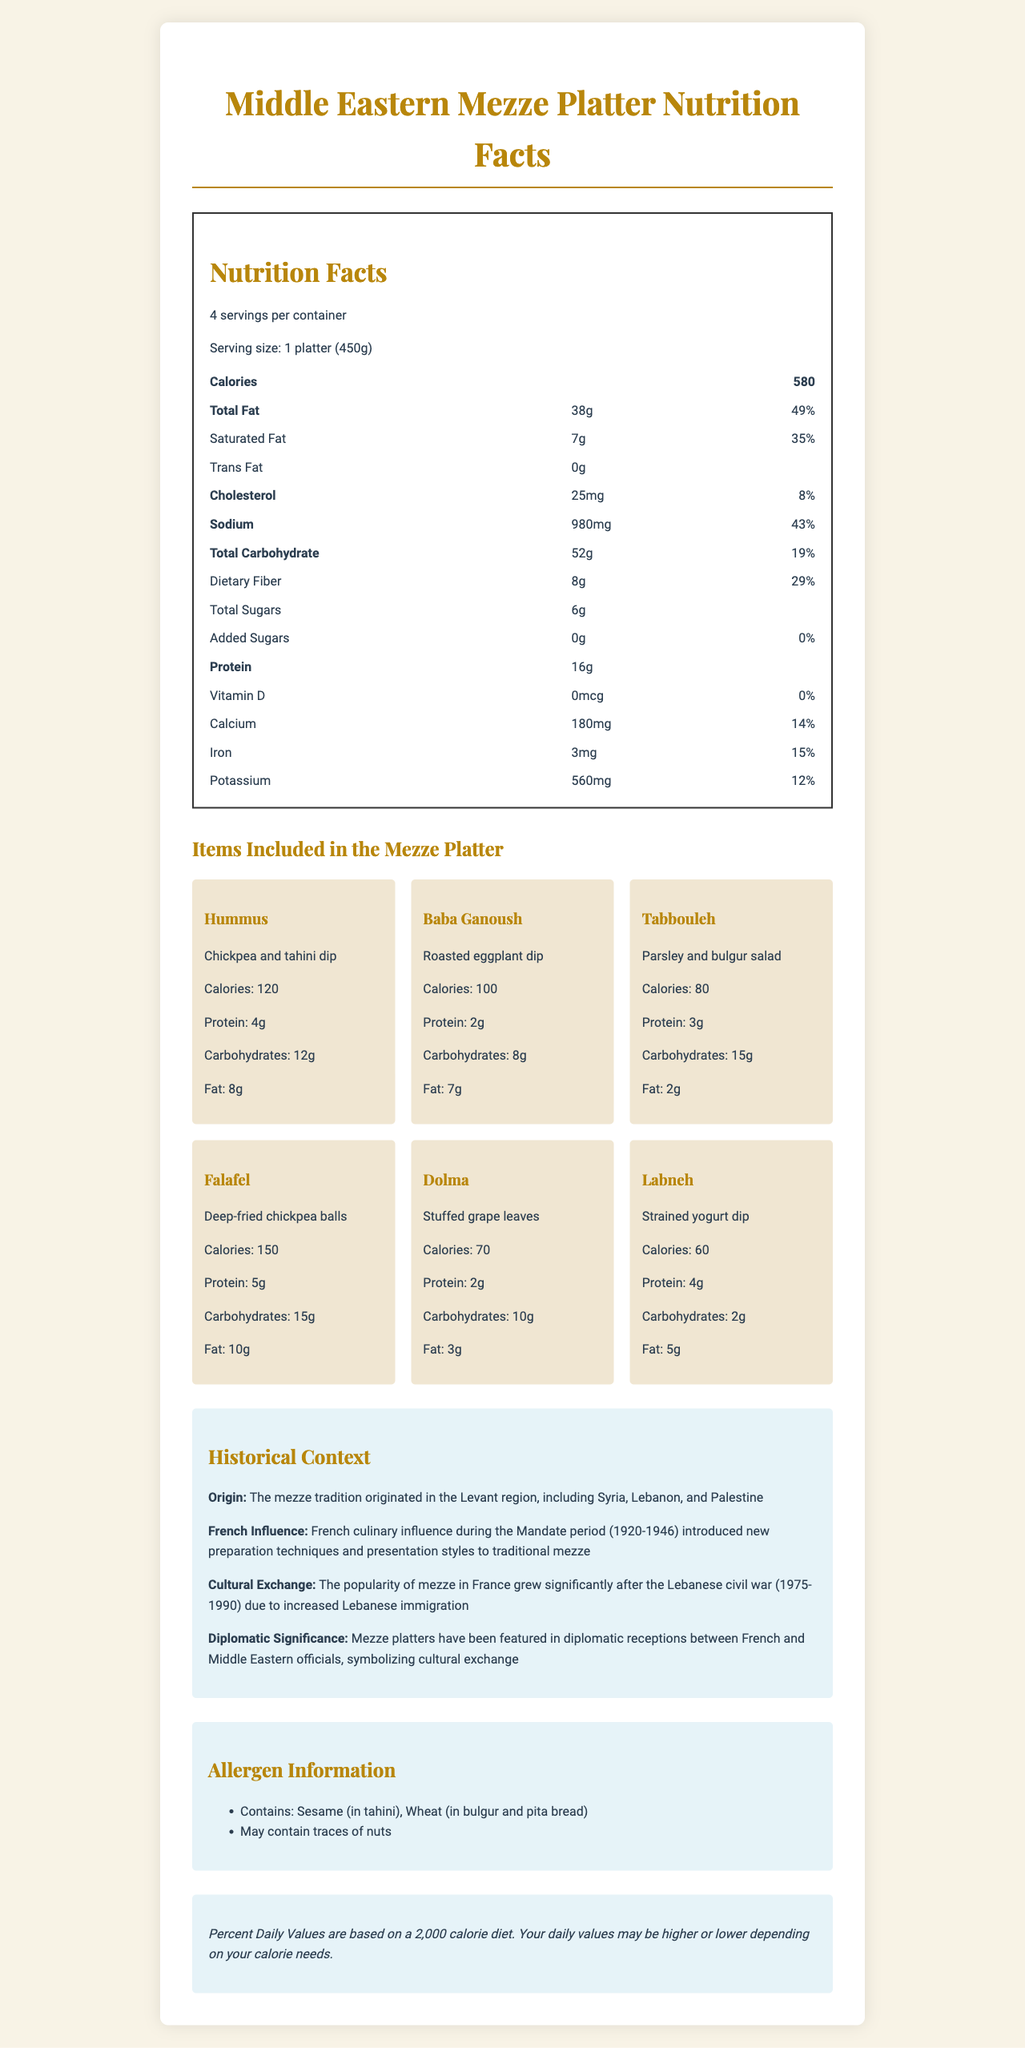what is the serving size for the mezze platter? The document specifies that the serving size is "1 platter (450g)".
Answer: 1 platter (450g) how many grams of total fat are in a serving of the mezze platter? According to the nutritional facts, the total fat per serving is listed as 38g.
Answer: 38g how many grams of dietary fiber does the mezze platter contain per serving? The nutrition label indicates that each serving contains 8g of dietary fiber.
Answer: 8g what is the daily value percentage for sodium in a serving of the mezze platter? The document states that the daily value percentage for sodium is 43%.
Answer: 43% how much protein is found in the Labneh dip included in the mezze platter? The details for Labneh indicate that it contains 4g of protein per serving.
Answer: 4g which item has the highest number of calories in the mezze platter? A. Hummus B. Falafel C. Tabbouleh D. Dolma The calorie content for each item is listed, with Falafel having the highest at 150 calories.
Answer: B how many grams of carbohydrates are in a serving of Falafel? A. 10g B. 15g C. 20g D. 25g The nutrition facts for Falafel state it contains 15g of carbohydrates.
Answer: B does the mezze platter contain any added sugars? The document shows 0g of added sugars, indicating there are no added sugars.
Answer: No is there any Vitamin D in the mezze platter? The Vitamin D content is listed as 0mcg with a 0% daily value, indicating there is no Vitamin D.
Answer: No summarize the historical context of the mezze platter. The historical context section covers the origin of the mezze tradition in the Levant, the influence of French culinary techniques during the Mandate period, its rise in popularity in France due to Lebanese immigration, and its diplomatic significance as a symbol of cultural exchange.
Answer: The mezze tradition originated in the Levant region (Syria, Lebanon, and Palestine). During the French Mandate period (1920-1946), French culinary influence introduced new techniques and presentation styles. The popularity of mezze in France grew after the Lebanese civil war (1975-1990) due to increased Lebanese immigration. Mezze platters have been used in diplomatic receptions to symbolize cultural exchange. how many servings per container does the mezze platter have? The nutrition label states that there are 4 servings per container.
Answer: 4 does the mezze platter include any allergen information about nuts? The allergen information section mentions that the platter "May contain traces of nuts".
Answer: Yes what preparation techniques were introduced to mezze during the French Mandate period? The document mentions that new preparation techniques were introduced during the Mandate period but does not specify what these techniques are.
Answer: Cannot be determined 